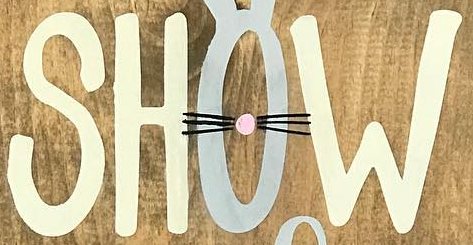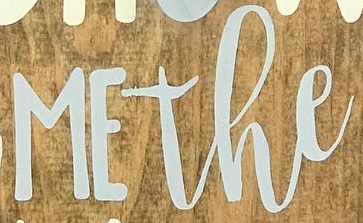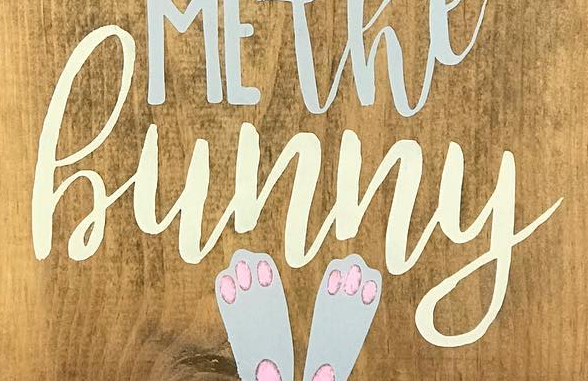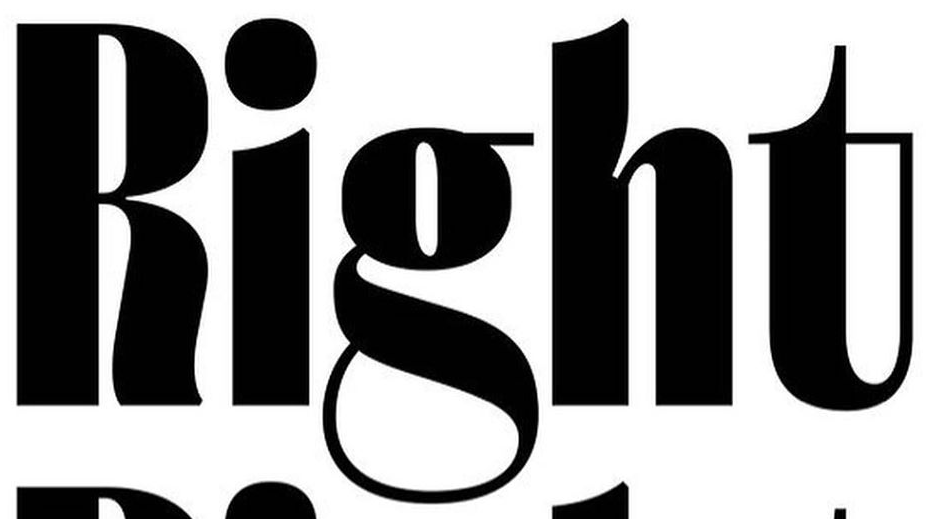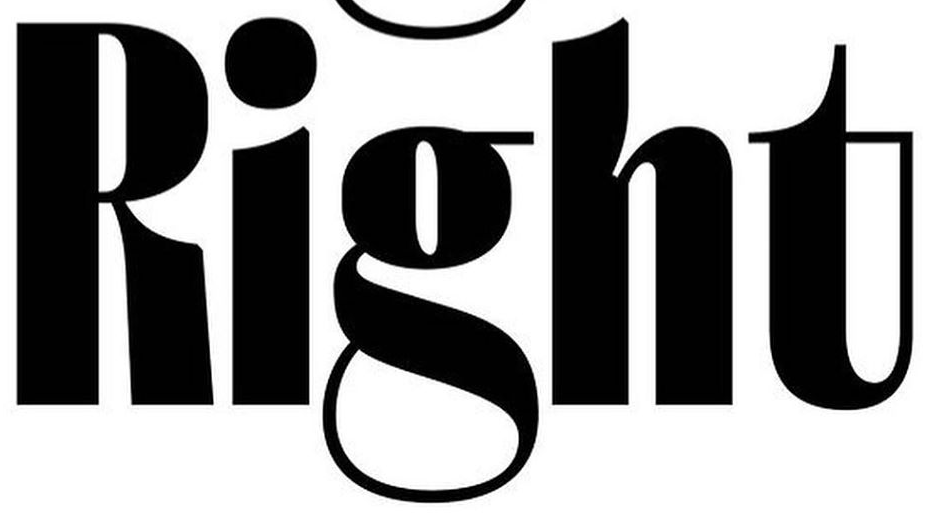Identify the words shown in these images in order, separated by a semicolon. SHOW; MEthe; hunny; Right; Right 